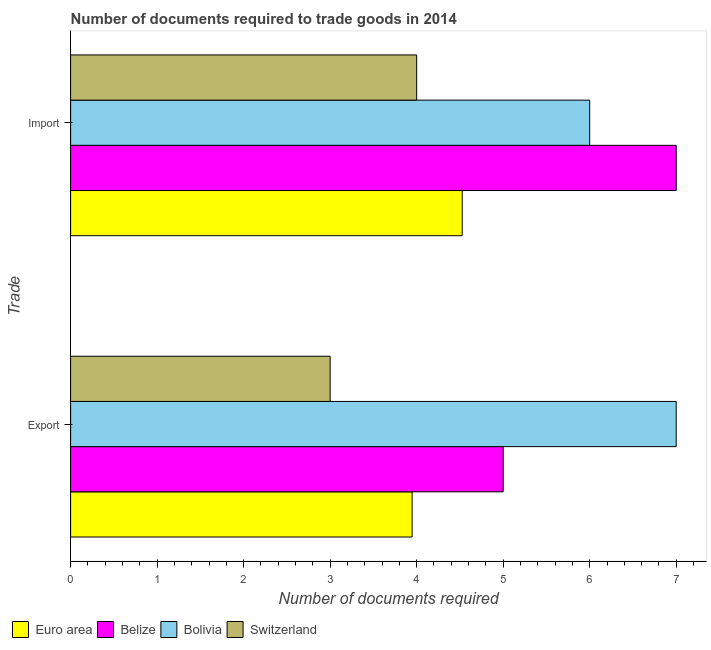How many different coloured bars are there?
Your answer should be compact. 4. What is the label of the 2nd group of bars from the top?
Offer a very short reply. Export. Across all countries, what is the maximum number of documents required to import goods?
Keep it short and to the point. 7. In which country was the number of documents required to import goods minimum?
Keep it short and to the point. Switzerland. What is the total number of documents required to import goods in the graph?
Your answer should be very brief. 21.53. What is the difference between the number of documents required to export goods in Switzerland and that in Bolivia?
Make the answer very short. -4. What is the difference between the number of documents required to export goods in Euro area and the number of documents required to import goods in Switzerland?
Your answer should be compact. -0.05. What is the average number of documents required to import goods per country?
Ensure brevity in your answer.  5.38. What is the ratio of the number of documents required to export goods in Bolivia to that in Euro area?
Make the answer very short. 1.77. What does the 3rd bar from the top in Import represents?
Your response must be concise. Belize. What does the 2nd bar from the bottom in Export represents?
Offer a terse response. Belize. How many countries are there in the graph?
Provide a succinct answer. 4. Are the values on the major ticks of X-axis written in scientific E-notation?
Give a very brief answer. No. Where does the legend appear in the graph?
Provide a succinct answer. Bottom left. How many legend labels are there?
Your answer should be compact. 4. What is the title of the graph?
Offer a terse response. Number of documents required to trade goods in 2014. Does "Sweden" appear as one of the legend labels in the graph?
Your response must be concise. No. What is the label or title of the X-axis?
Keep it short and to the point. Number of documents required. What is the label or title of the Y-axis?
Provide a succinct answer. Trade. What is the Number of documents required in Euro area in Export?
Offer a very short reply. 3.95. What is the Number of documents required of Belize in Export?
Make the answer very short. 5. What is the Number of documents required of Switzerland in Export?
Offer a terse response. 3. What is the Number of documents required in Euro area in Import?
Provide a succinct answer. 4.53. What is the Number of documents required in Belize in Import?
Your answer should be very brief. 7. What is the Number of documents required of Bolivia in Import?
Provide a short and direct response. 6. Across all Trade, what is the maximum Number of documents required of Euro area?
Keep it short and to the point. 4.53. Across all Trade, what is the minimum Number of documents required of Euro area?
Your response must be concise. 3.95. Across all Trade, what is the minimum Number of documents required of Belize?
Your answer should be very brief. 5. Across all Trade, what is the minimum Number of documents required in Bolivia?
Offer a very short reply. 6. Across all Trade, what is the minimum Number of documents required of Switzerland?
Your answer should be compact. 3. What is the total Number of documents required in Euro area in the graph?
Give a very brief answer. 8.47. What is the total Number of documents required in Switzerland in the graph?
Make the answer very short. 7. What is the difference between the Number of documents required in Euro area in Export and that in Import?
Make the answer very short. -0.58. What is the difference between the Number of documents required in Belize in Export and that in Import?
Provide a short and direct response. -2. What is the difference between the Number of documents required in Switzerland in Export and that in Import?
Provide a succinct answer. -1. What is the difference between the Number of documents required of Euro area in Export and the Number of documents required of Belize in Import?
Your answer should be very brief. -3.05. What is the difference between the Number of documents required in Euro area in Export and the Number of documents required in Bolivia in Import?
Your answer should be very brief. -2.05. What is the difference between the Number of documents required of Euro area in Export and the Number of documents required of Switzerland in Import?
Provide a succinct answer. -0.05. What is the difference between the Number of documents required of Belize in Export and the Number of documents required of Bolivia in Import?
Offer a terse response. -1. What is the difference between the Number of documents required in Belize in Export and the Number of documents required in Switzerland in Import?
Provide a succinct answer. 1. What is the average Number of documents required in Euro area per Trade?
Give a very brief answer. 4.24. What is the average Number of documents required of Bolivia per Trade?
Your response must be concise. 6.5. What is the average Number of documents required in Switzerland per Trade?
Provide a short and direct response. 3.5. What is the difference between the Number of documents required in Euro area and Number of documents required in Belize in Export?
Your answer should be compact. -1.05. What is the difference between the Number of documents required in Euro area and Number of documents required in Bolivia in Export?
Your response must be concise. -3.05. What is the difference between the Number of documents required of Euro area and Number of documents required of Switzerland in Export?
Provide a succinct answer. 0.95. What is the difference between the Number of documents required in Belize and Number of documents required in Bolivia in Export?
Offer a terse response. -2. What is the difference between the Number of documents required of Belize and Number of documents required of Switzerland in Export?
Provide a short and direct response. 2. What is the difference between the Number of documents required of Euro area and Number of documents required of Belize in Import?
Your answer should be very brief. -2.47. What is the difference between the Number of documents required of Euro area and Number of documents required of Bolivia in Import?
Your answer should be compact. -1.47. What is the difference between the Number of documents required in Euro area and Number of documents required in Switzerland in Import?
Ensure brevity in your answer.  0.53. What is the ratio of the Number of documents required of Euro area in Export to that in Import?
Provide a short and direct response. 0.87. What is the difference between the highest and the second highest Number of documents required of Euro area?
Provide a short and direct response. 0.58. What is the difference between the highest and the second highest Number of documents required in Switzerland?
Your response must be concise. 1. What is the difference between the highest and the lowest Number of documents required in Euro area?
Keep it short and to the point. 0.58. What is the difference between the highest and the lowest Number of documents required of Belize?
Provide a short and direct response. 2. What is the difference between the highest and the lowest Number of documents required of Bolivia?
Offer a very short reply. 1. 